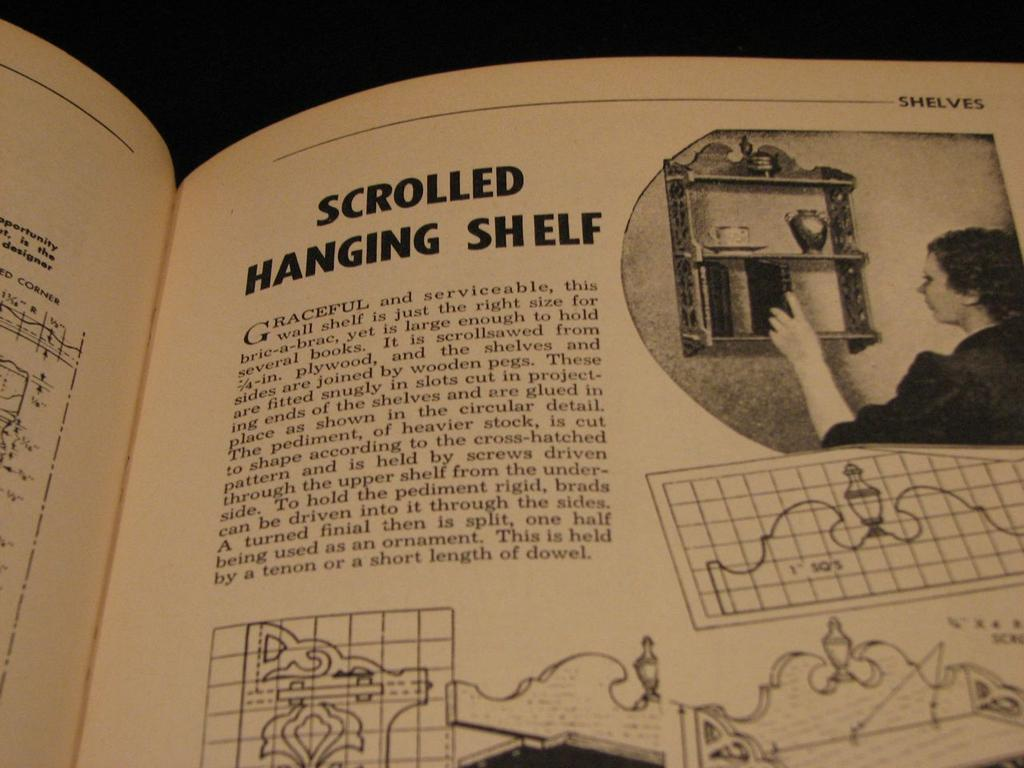<image>
Summarize the visual content of the image. A set of plans and instructions for DIY scrolled hanging shelf. 